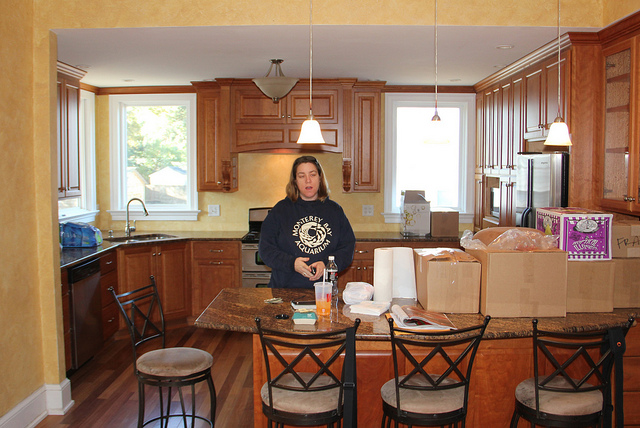Please transcribe the text in this image. MONTEREY BAY AQUARIUM FRA 